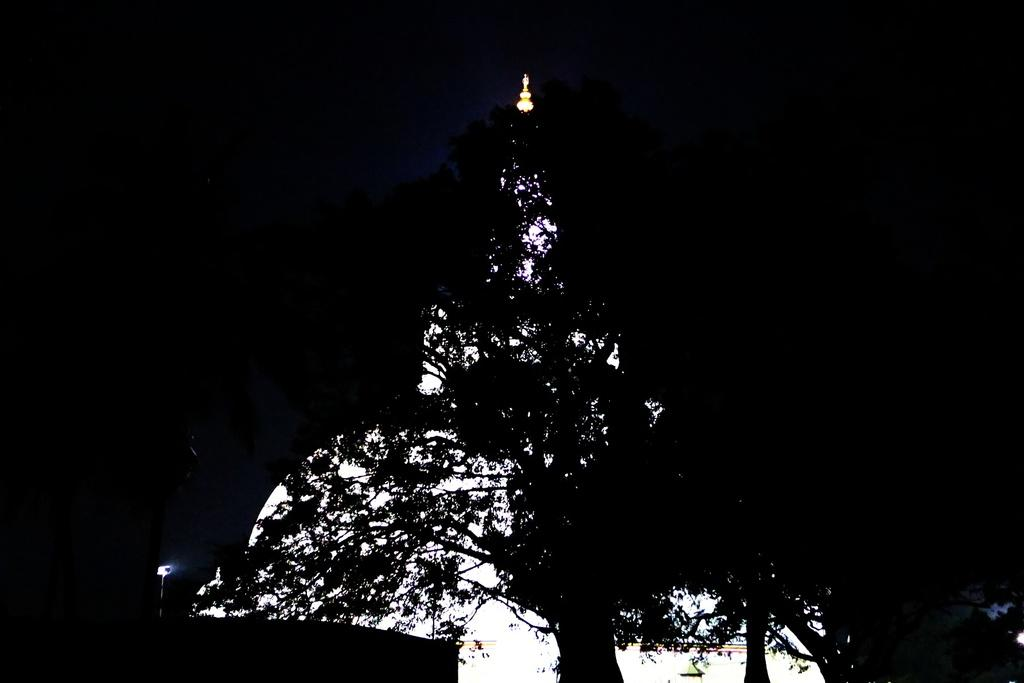What type of vegetation is present at the bottom of the image? There are trees at the bottom of the image. What part of the natural environment is visible in the image? The sky is visible in the image. What is the color of the background in the image? The background of the image appears to be black in color. Can you describe the lighting conditions in the image? The image might have been taken in the dark, as the background is black. What type of payment is being made in the image? There is no payment being made in the image; it features trees and a black background. Can you describe the road conditions in the image? There is no road present in the image; it features trees and a black background. 